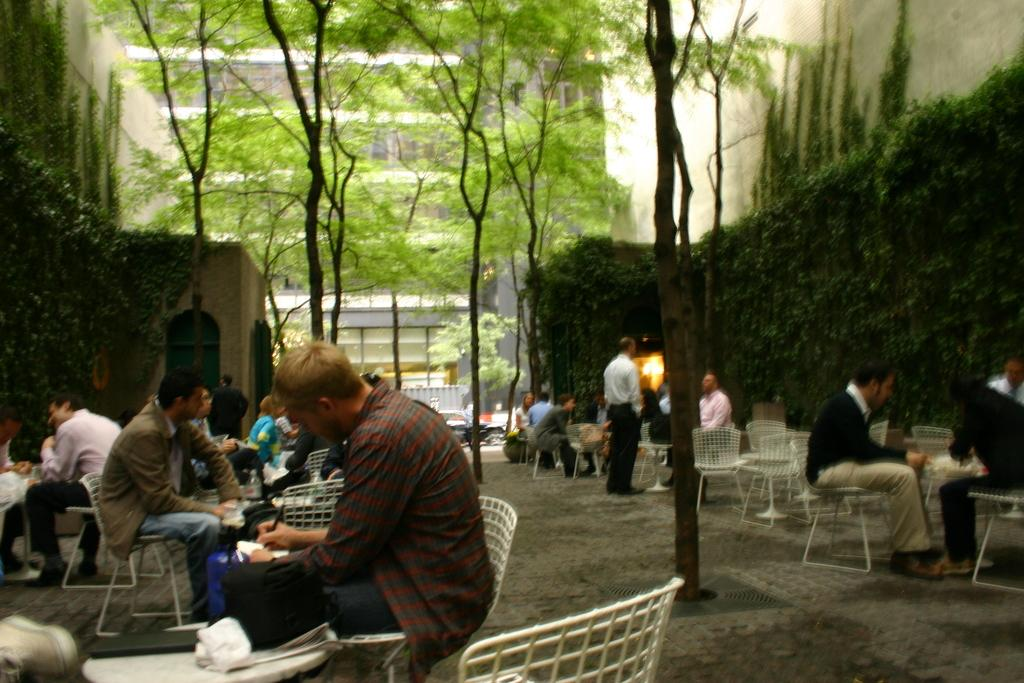What can you describe the people sitting on the right side of the image? There are persons sitting on a chair at the right side of the image. How many people are sitting in the image? There are other people sitting in the image besides the ones on the right side. What can be seen in the background of the image? There is a tree, a building, and a railing in the background of the image. What grade did the person sitting on the left side of the image receive on their last exam? There is no person sitting on the left side of the image, and no information about exams or grades is provided in the facts. 